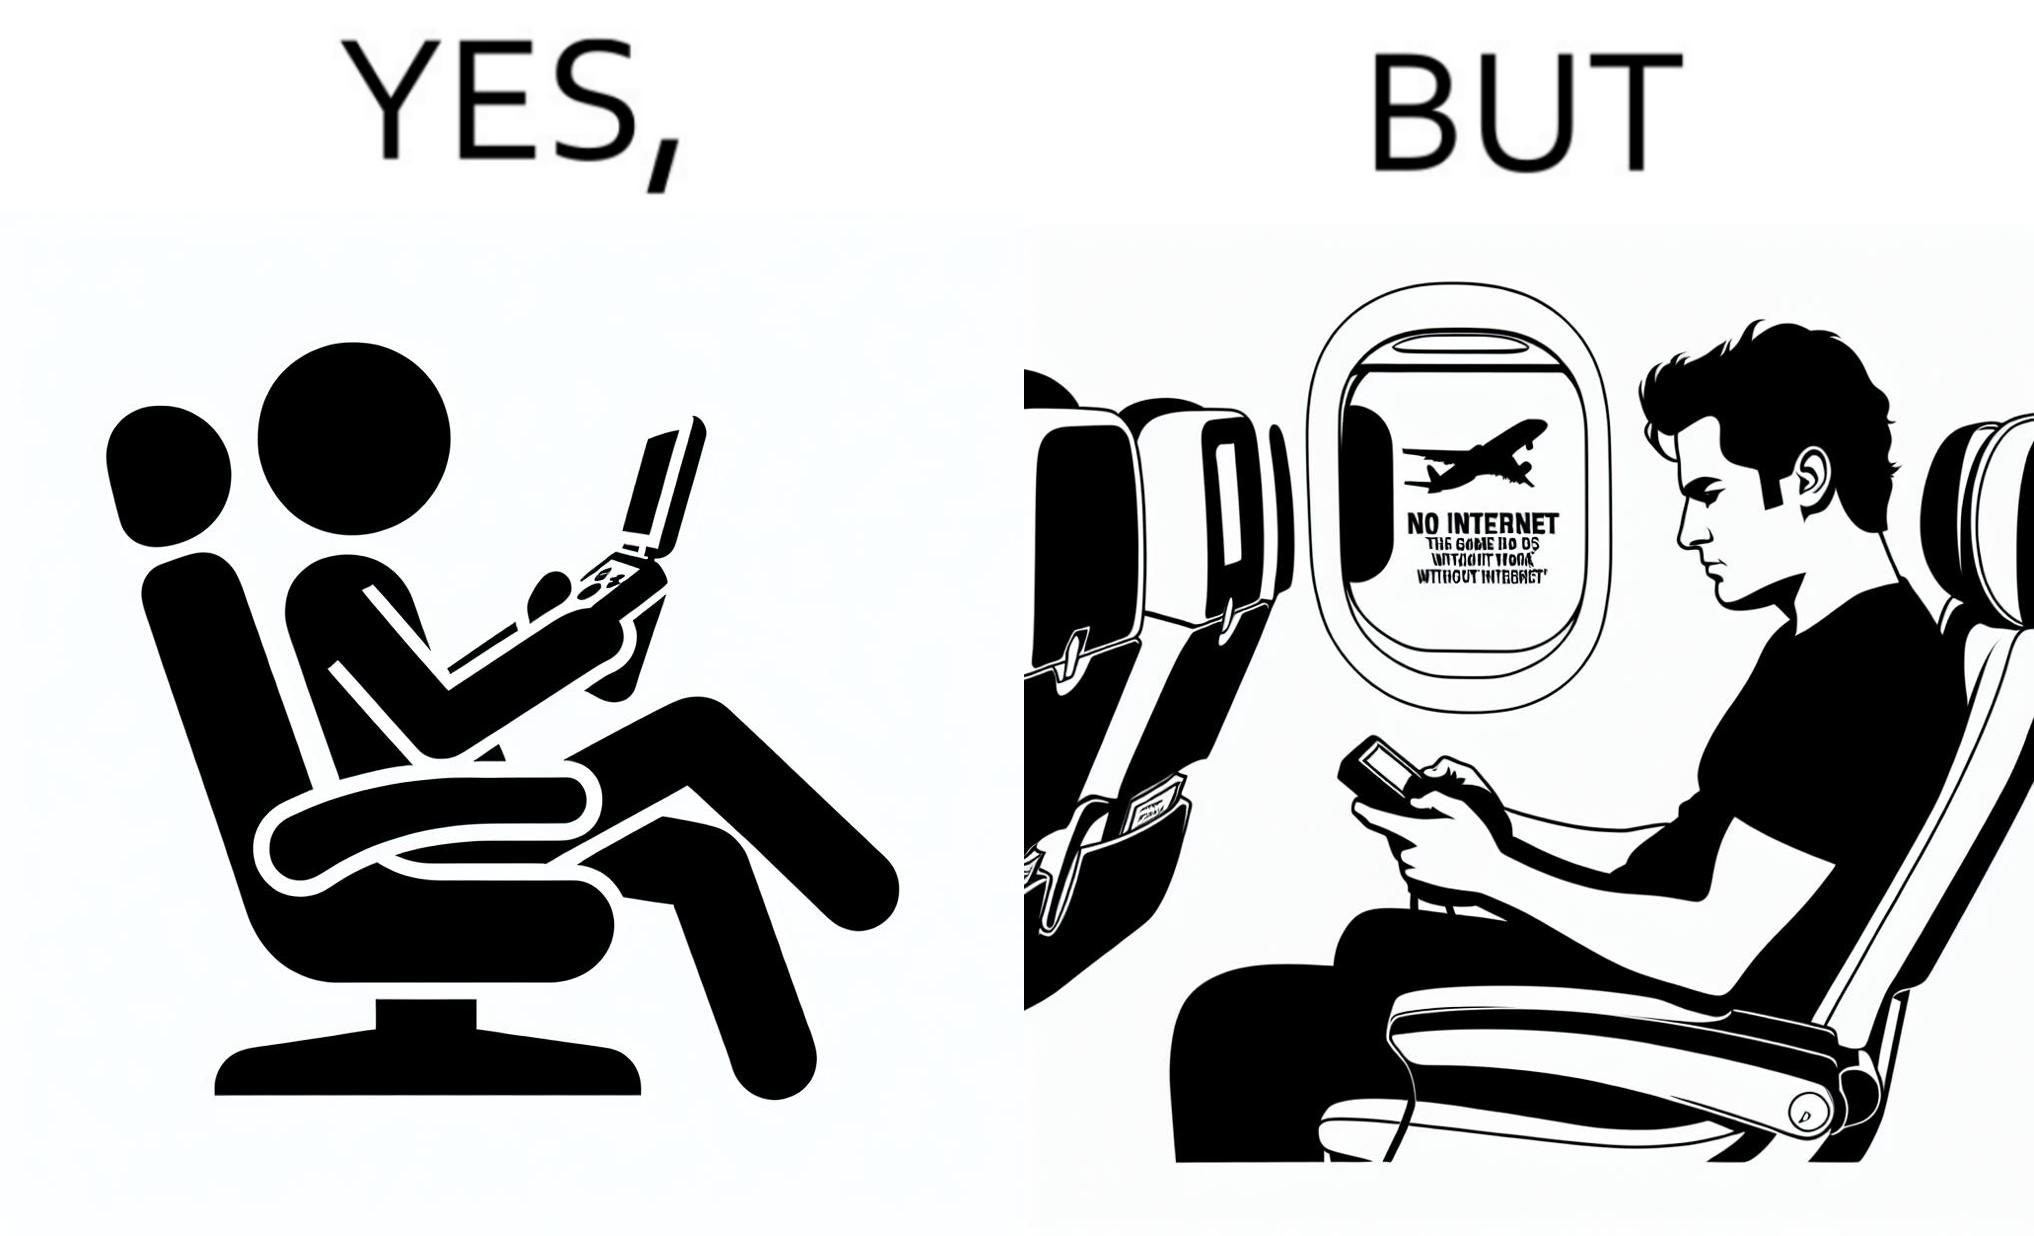Is this a satirical image? Yes, this image is satirical. 